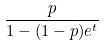<formula> <loc_0><loc_0><loc_500><loc_500>\frac { p } { 1 - ( 1 - p ) e ^ { t } }</formula> 